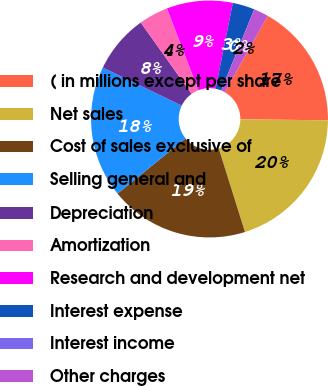Convert chart to OTSL. <chart><loc_0><loc_0><loc_500><loc_500><pie_chart><fcel>( in millions except per share<fcel>Net sales<fcel>Cost of sales exclusive of<fcel>Selling general and<fcel>Depreciation<fcel>Amortization<fcel>Research and development net<fcel>Interest expense<fcel>Interest income<fcel>Other charges<nl><fcel>16.99%<fcel>19.99%<fcel>18.99%<fcel>17.99%<fcel>8.0%<fcel>4.01%<fcel>9.0%<fcel>3.01%<fcel>0.01%<fcel>2.01%<nl></chart> 